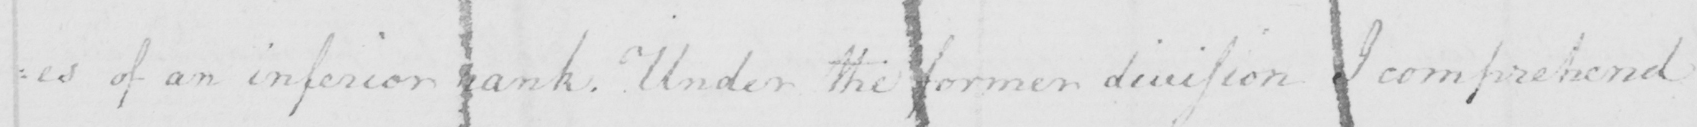What is written in this line of handwriting? =es of an inferior rank . Under the former division I comprehend 